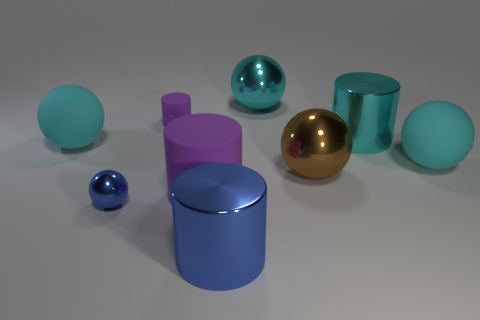Subtract all yellow cylinders. How many cyan balls are left? 3 Subtract 1 cylinders. How many cylinders are left? 3 Subtract all blue spheres. How many spheres are left? 4 Subtract all cyan metal balls. How many balls are left? 4 Subtract all green cylinders. Subtract all green spheres. How many cylinders are left? 4 Add 1 large cyan metallic objects. How many objects exist? 10 Add 2 cyan metal cylinders. How many cyan metal cylinders are left? 3 Add 9 tiny purple cylinders. How many tiny purple cylinders exist? 10 Subtract 1 blue cylinders. How many objects are left? 8 Subtract all cylinders. How many objects are left? 5 